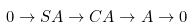<formula> <loc_0><loc_0><loc_500><loc_500>0 \rightarrow S A \rightarrow C A \rightarrow A \rightarrow 0</formula> 